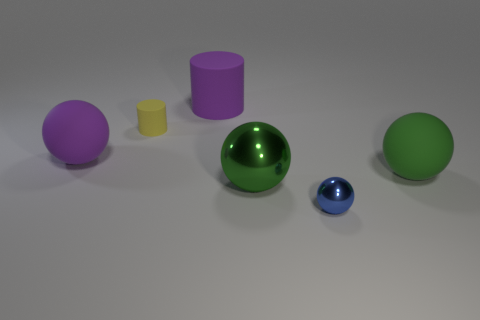Add 3 big cyan matte spheres. How many objects exist? 9 Subtract all cylinders. How many objects are left? 4 Subtract 0 yellow spheres. How many objects are left? 6 Subtract all large green matte things. Subtract all purple rubber cylinders. How many objects are left? 4 Add 5 large purple matte cylinders. How many large purple matte cylinders are left? 6 Add 3 tiny shiny cubes. How many tiny shiny cubes exist? 3 